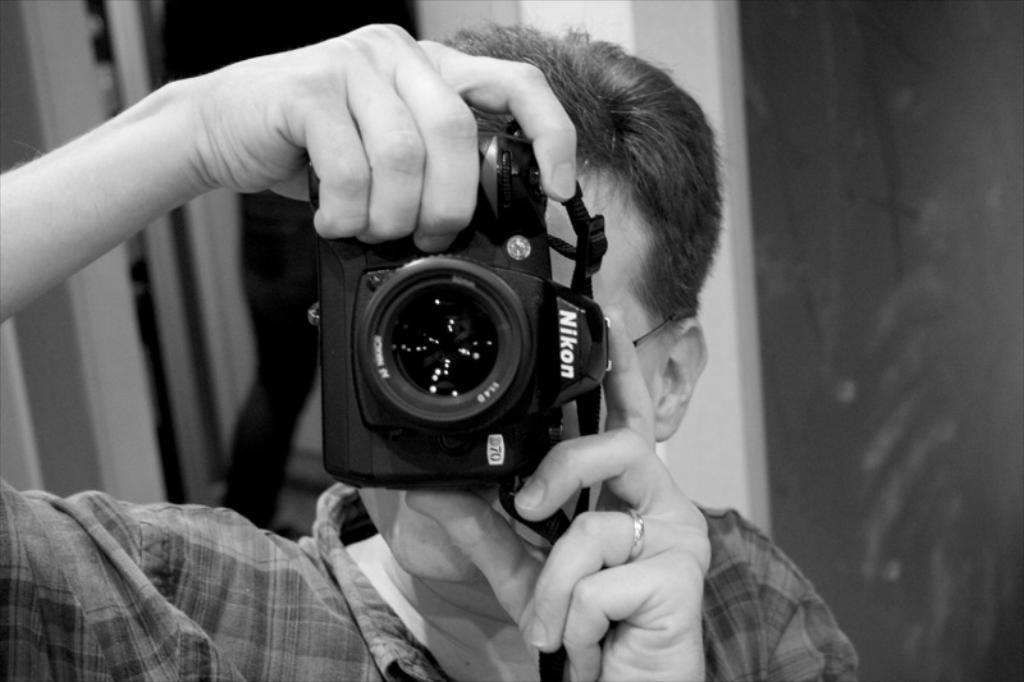In one or two sentences, can you explain what this image depicts? In this image we can see a man holding a camera in his hands and clicking the pictures. 